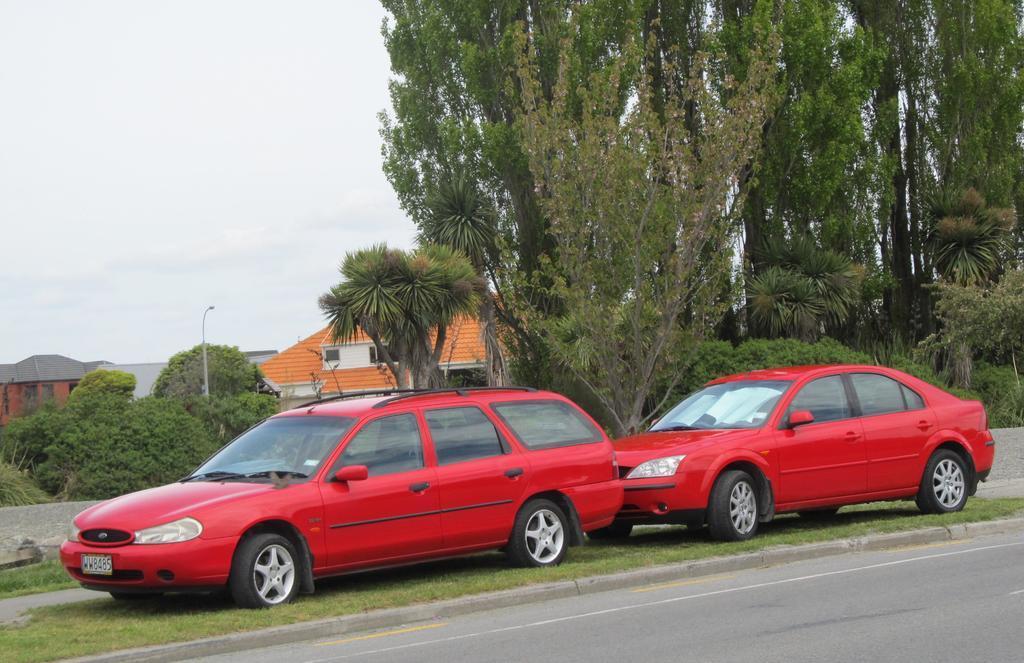How would you summarize this image in a sentence or two? In the image in the center, we can see two vehicles, which are in red color. In the background, we can see the sky, clouds, trees, buildings, one pole, grass and road. 